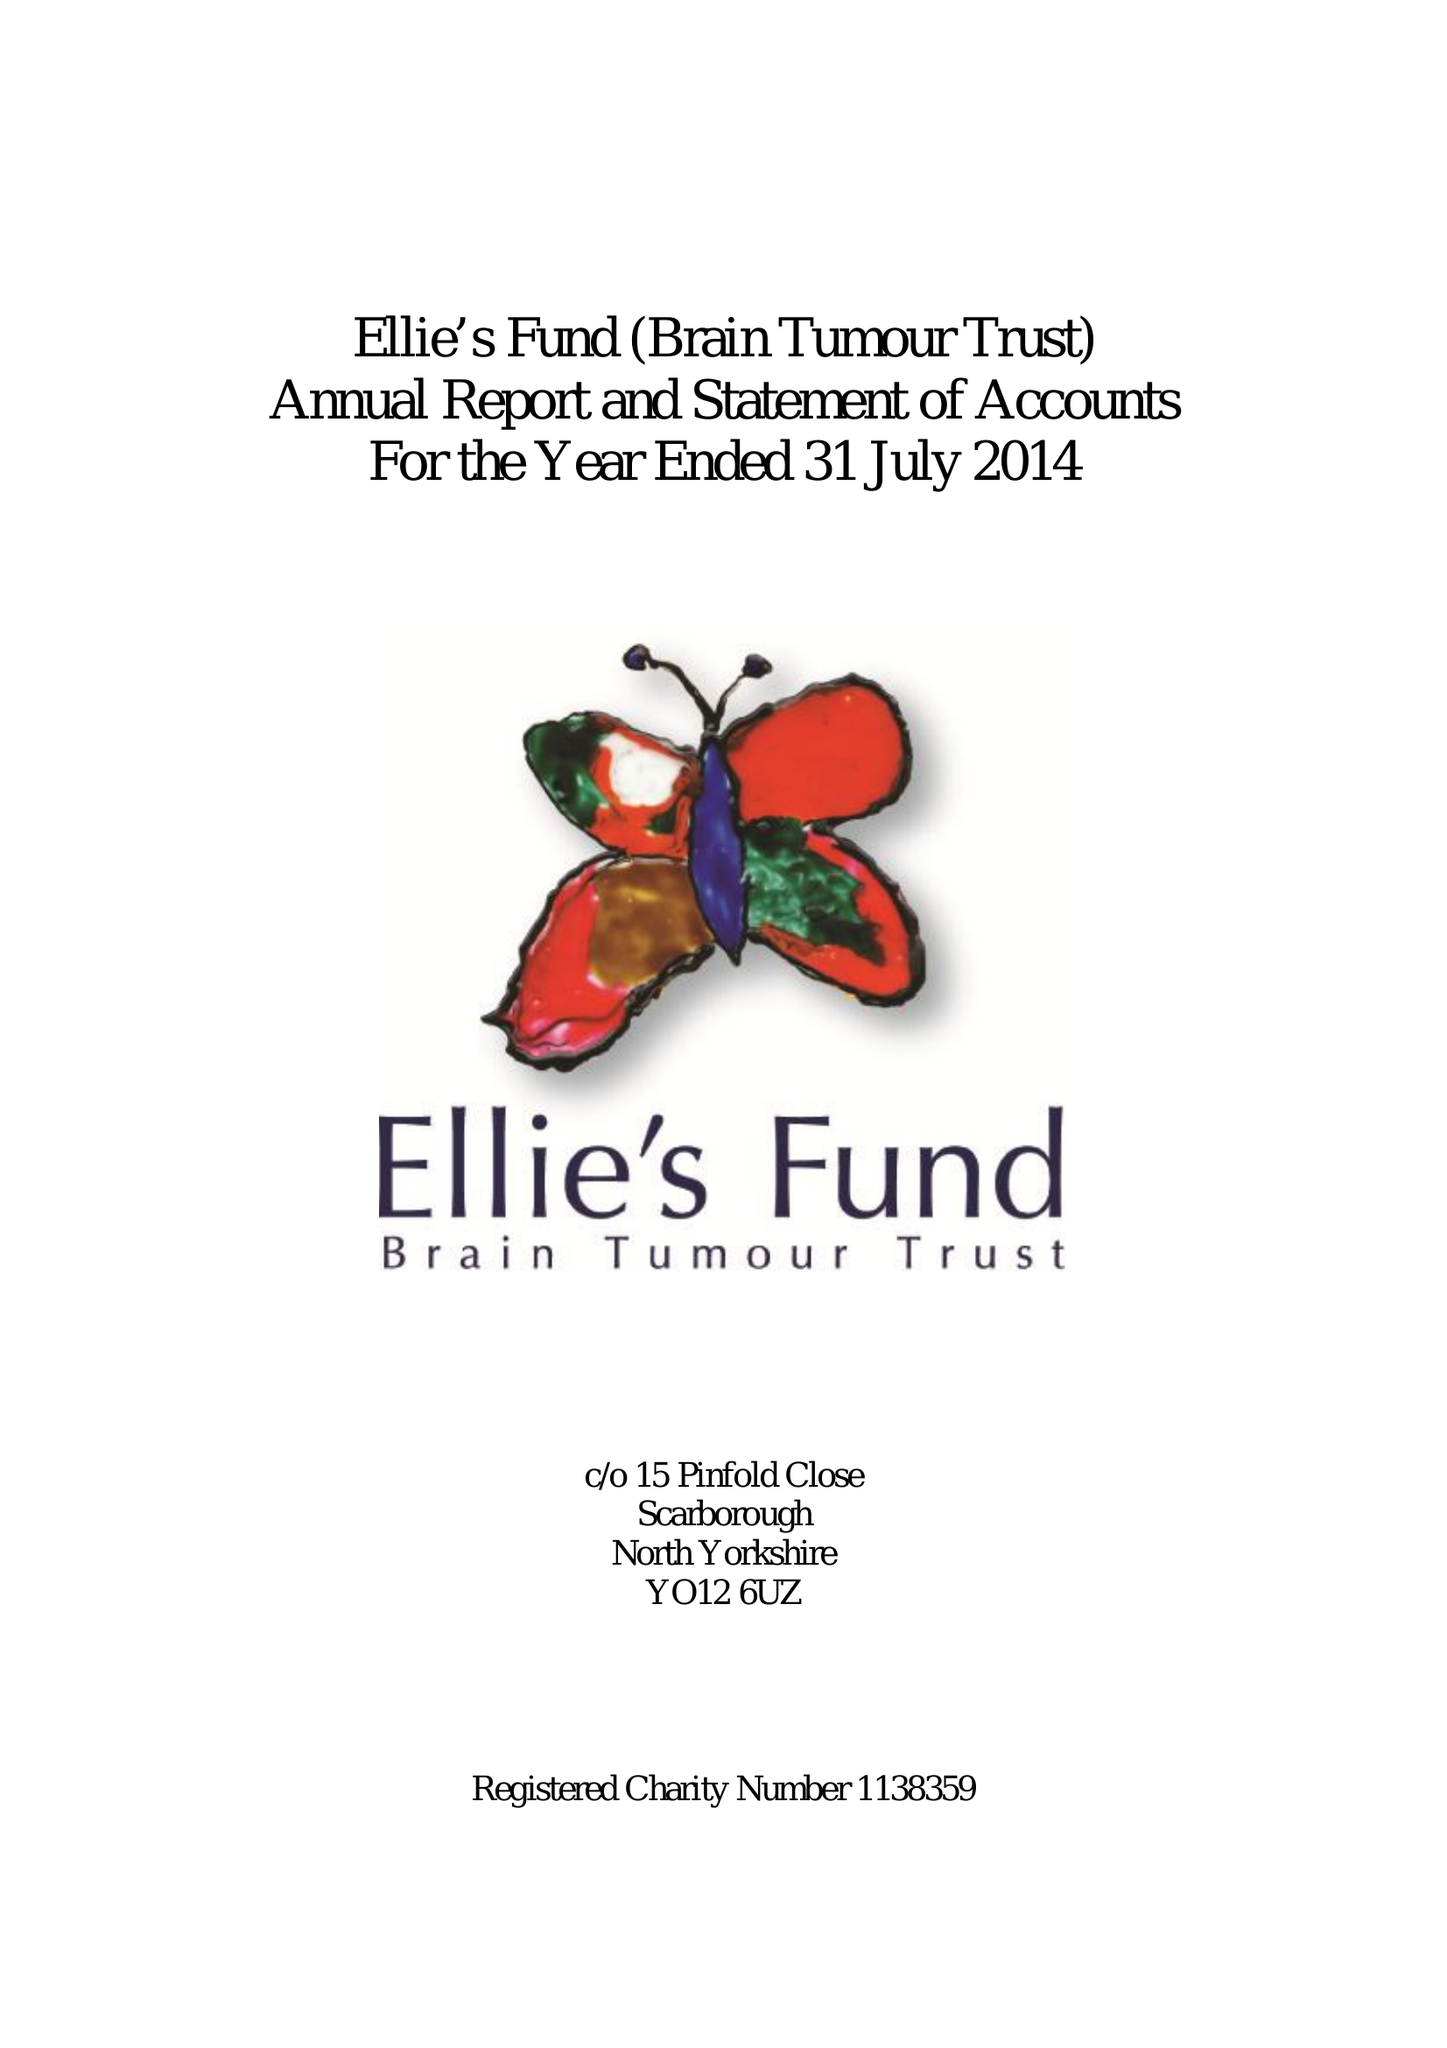What is the value for the address__street_line?
Answer the question using a single word or phrase. None 